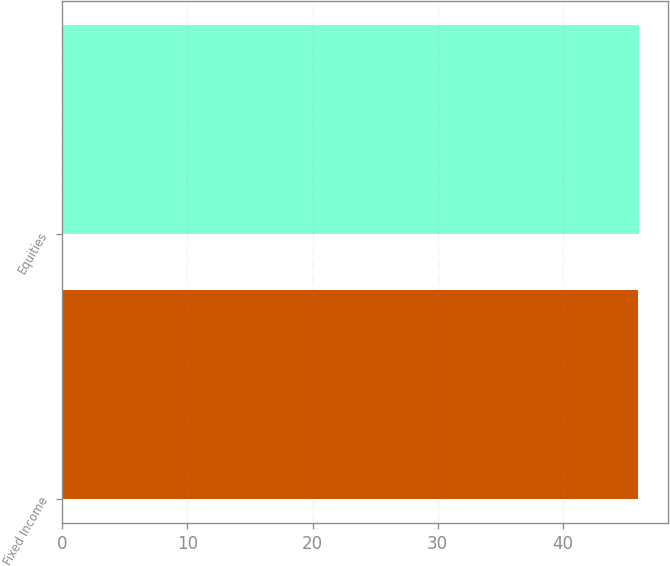Convert chart. <chart><loc_0><loc_0><loc_500><loc_500><bar_chart><fcel>Fixed Income<fcel>Equities<nl><fcel>46<fcel>46.1<nl></chart> 